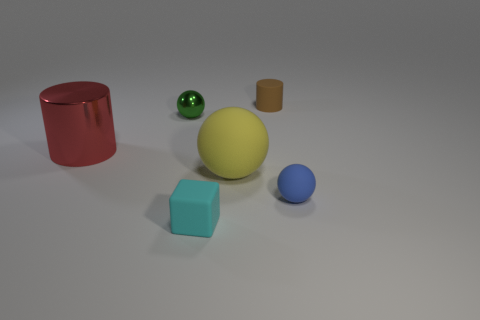What material is the tiny sphere left of the tiny rubber object behind the tiny ball to the left of the small blue rubber thing?
Offer a terse response. Metal. There is a shiny object to the right of the big red cylinder; is its size the same as the matte object to the right of the tiny cylinder?
Offer a terse response. Yes. What number of other things are there of the same material as the yellow thing
Provide a short and direct response. 3. How many shiny things are big cyan cylinders or small cyan blocks?
Give a very brief answer. 0. Is the number of green spheres less than the number of things?
Your answer should be very brief. Yes. Is the size of the green metallic ball the same as the thing in front of the blue rubber sphere?
Your response must be concise. Yes. Is there any other thing that has the same shape as the big shiny thing?
Your response must be concise. Yes. How big is the green shiny thing?
Keep it short and to the point. Small. Is the number of rubber cubes that are behind the brown matte cylinder less than the number of gray cylinders?
Ensure brevity in your answer.  No. Is the size of the green object the same as the matte cube?
Your response must be concise. Yes. 